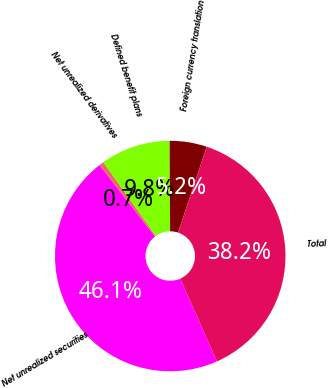<chart> <loc_0><loc_0><loc_500><loc_500><pie_chart><fcel>Net unrealized securities<fcel>Net unrealized derivatives<fcel>Defined benefit plans<fcel>Foreign currency translation<fcel>Total<nl><fcel>46.14%<fcel>0.66%<fcel>9.76%<fcel>5.21%<fcel>38.23%<nl></chart> 